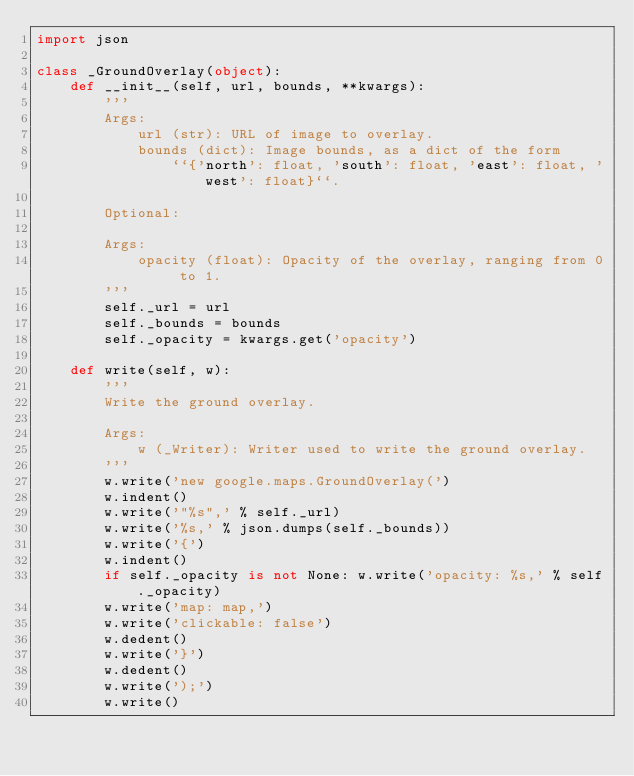Convert code to text. <code><loc_0><loc_0><loc_500><loc_500><_Python_>import json

class _GroundOverlay(object):
    def __init__(self, url, bounds, **kwargs):
        '''
        Args:
            url (str): URL of image to overlay.
            bounds (dict): Image bounds, as a dict of the form
                ``{'north': float, 'south': float, 'east': float, 'west': float}``.

        Optional:

        Args:
            opacity (float): Opacity of the overlay, ranging from 0 to 1.
        '''
        self._url = url
        self._bounds = bounds
        self._opacity = kwargs.get('opacity')

    def write(self, w):
        '''
        Write the ground overlay.

        Args:
            w (_Writer): Writer used to write the ground overlay.
        '''
        w.write('new google.maps.GroundOverlay(')
        w.indent()
        w.write('"%s",' % self._url)
        w.write('%s,' % json.dumps(self._bounds))
        w.write('{')
        w.indent()
        if self._opacity is not None: w.write('opacity: %s,' % self._opacity)
        w.write('map: map,')
        w.write('clickable: false')
        w.dedent()
        w.write('}')
        w.dedent()
        w.write(');')
        w.write()
</code> 